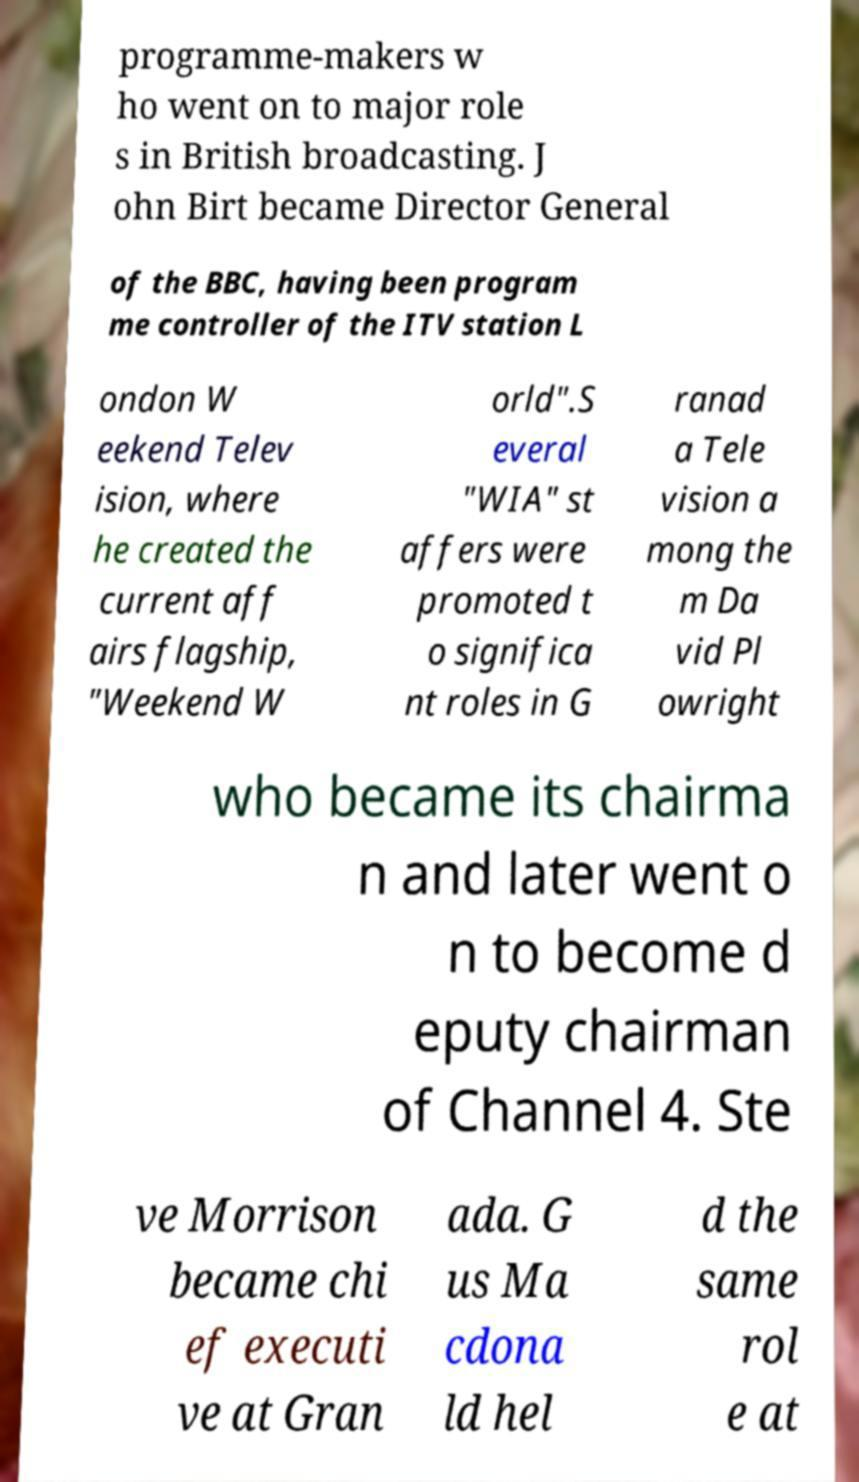Please read and relay the text visible in this image. What does it say? programme-makers w ho went on to major role s in British broadcasting. J ohn Birt became Director General of the BBC, having been program me controller of the ITV station L ondon W eekend Telev ision, where he created the current aff airs flagship, "Weekend W orld".S everal "WIA" st affers were promoted t o significa nt roles in G ranad a Tele vision a mong the m Da vid Pl owright who became its chairma n and later went o n to become d eputy chairman of Channel 4. Ste ve Morrison became chi ef executi ve at Gran ada. G us Ma cdona ld hel d the same rol e at 